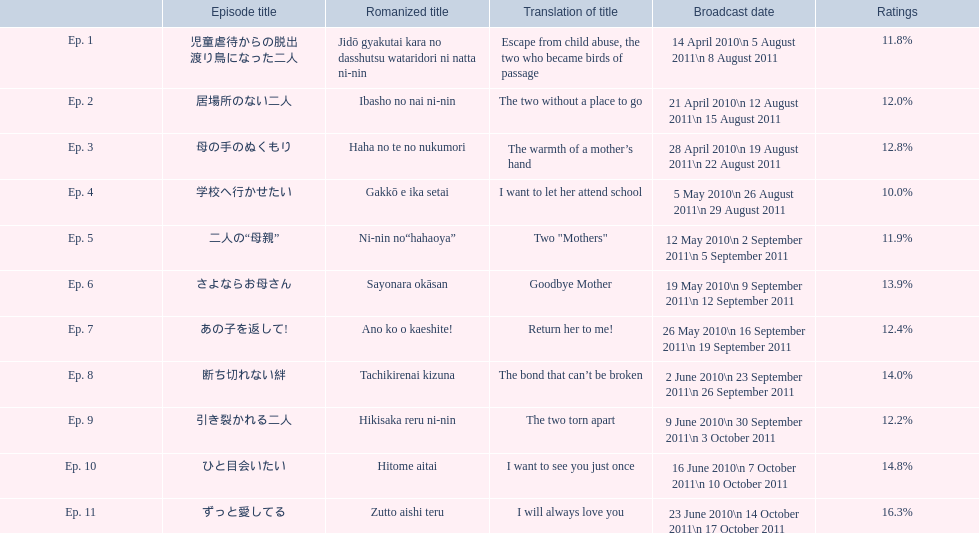What is the name of epsiode 8? 断ち切れない絆. What were this episodes ratings? 14.0%. 